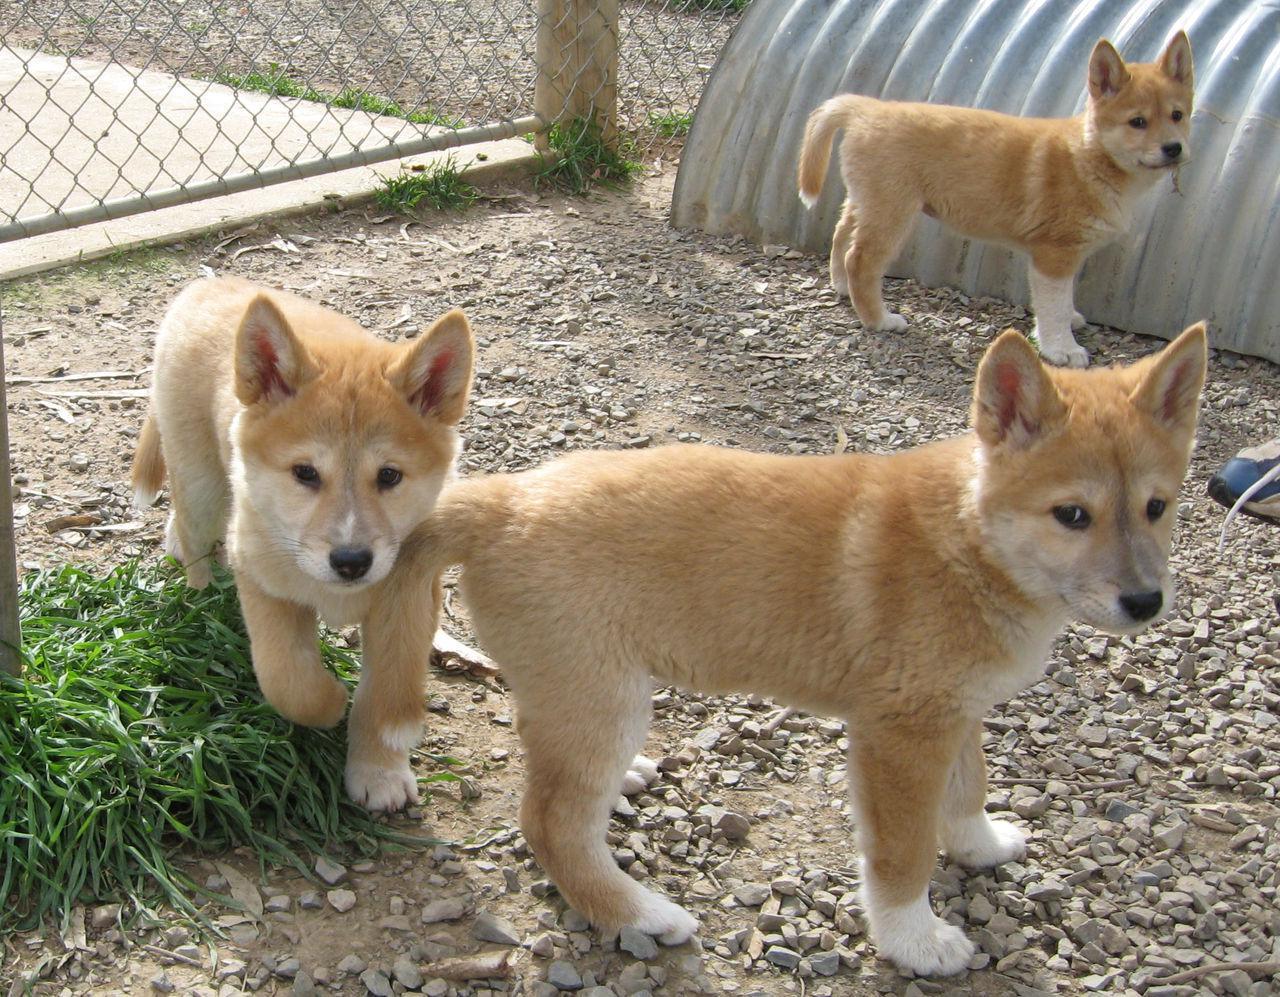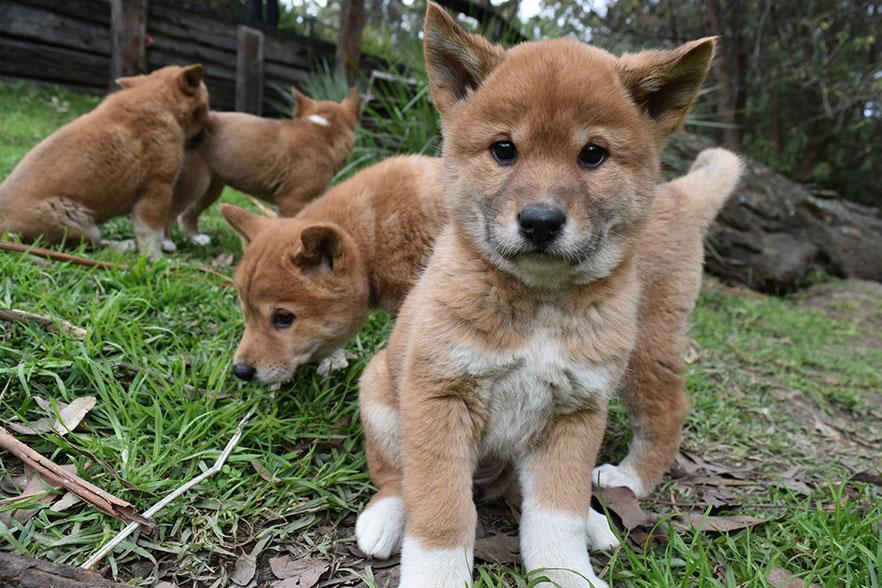The first image is the image on the left, the second image is the image on the right. Analyze the images presented: Is the assertion "There are more canines in the left image than the right." valid? Answer yes or no. No. 